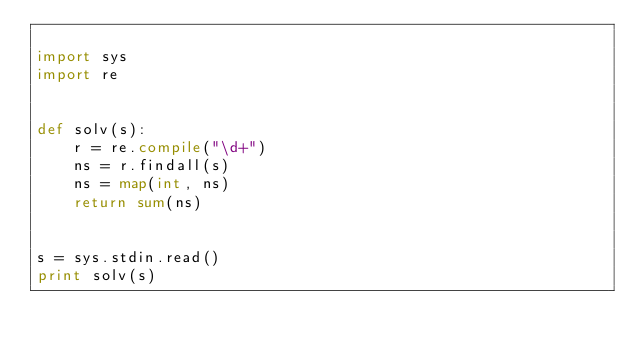Convert code to text. <code><loc_0><loc_0><loc_500><loc_500><_Python_>
import sys
import re


def solv(s):
    r = re.compile("\d+")
    ns = r.findall(s)
    ns = map(int, ns)
    return sum(ns)


s = sys.stdin.read()
print solv(s)</code> 